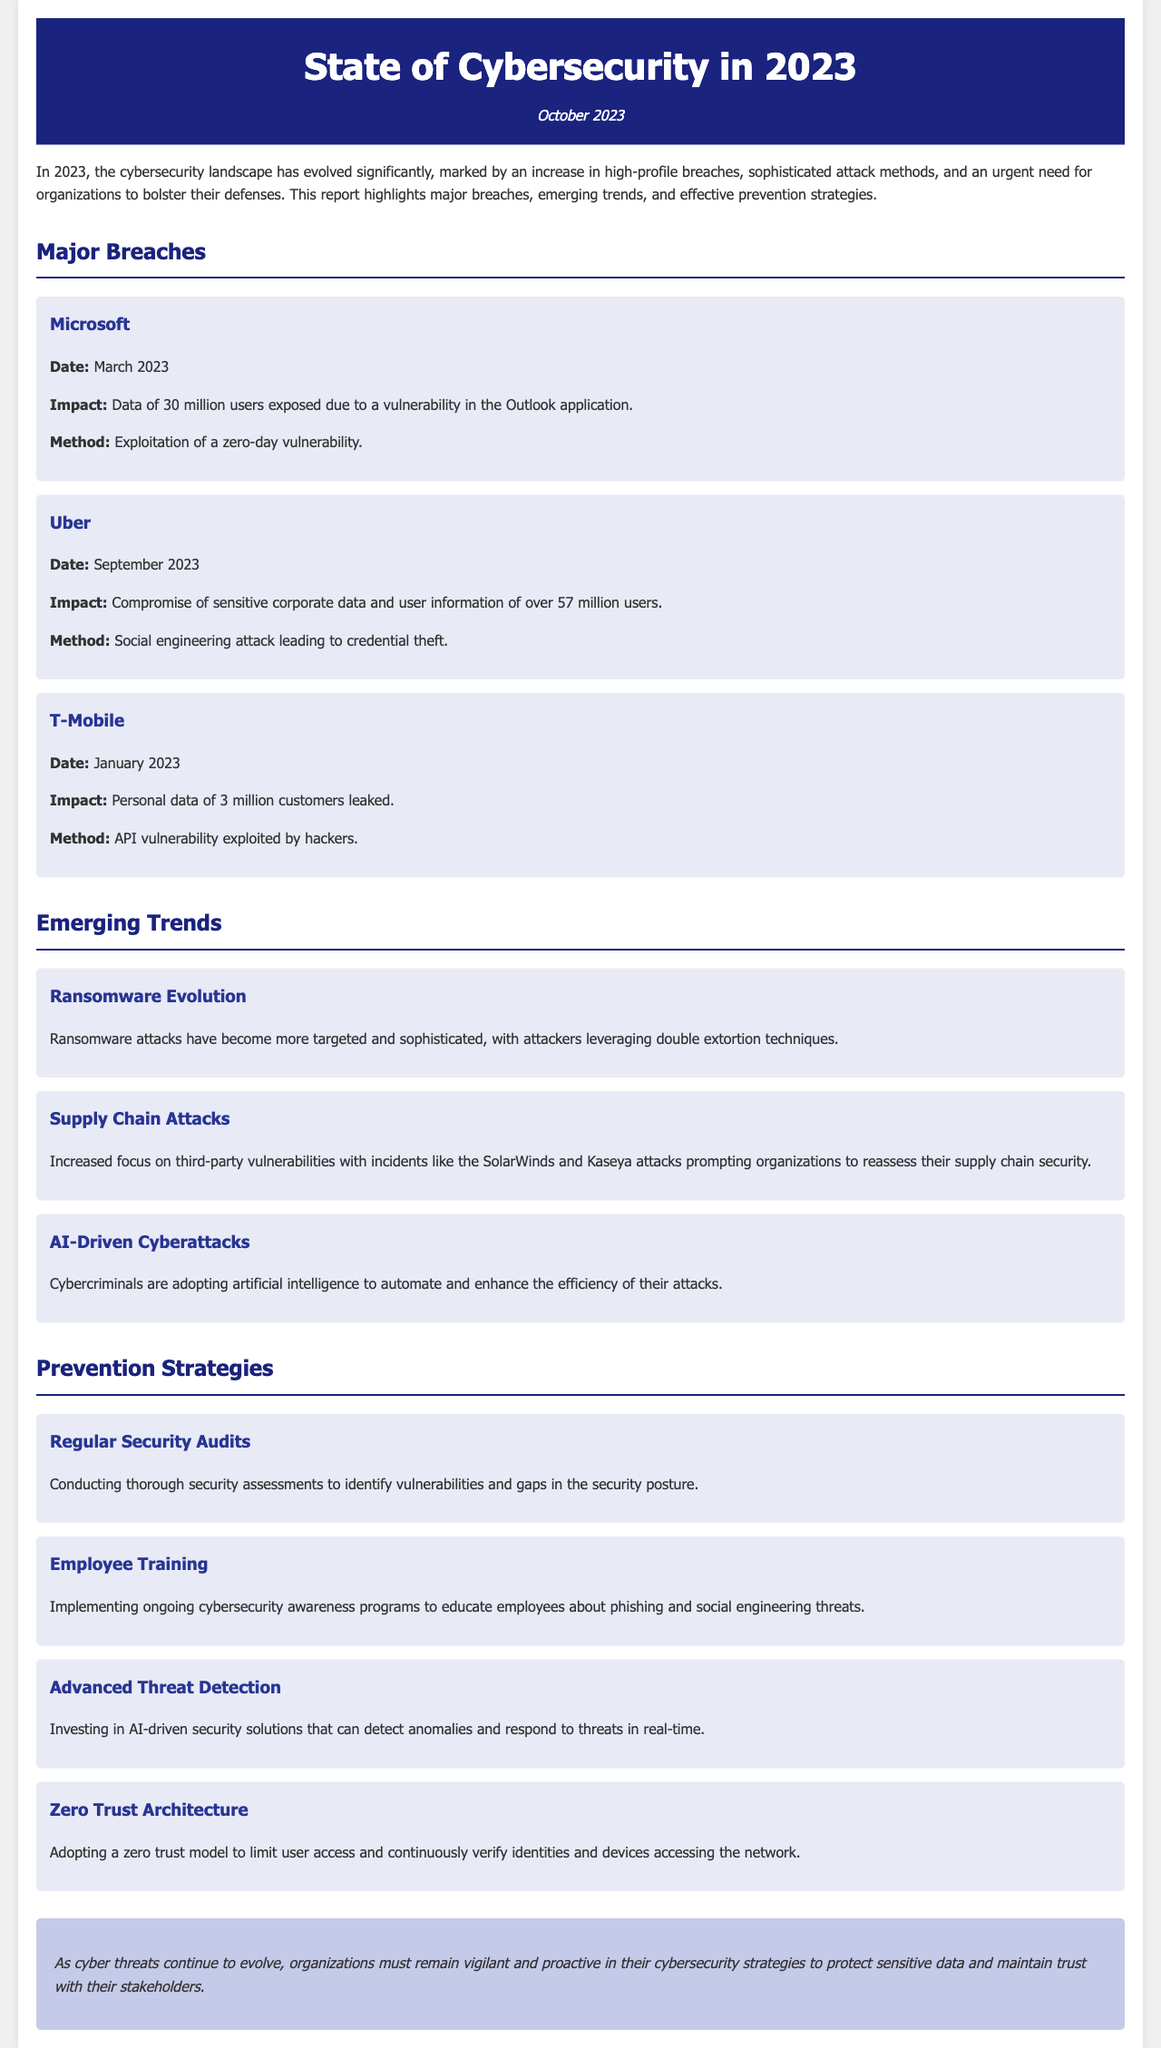What major breach occurred at Microsoft? The report specifies that Microsoft experienced a breach in March 2023 where data of 30 million users was exposed.
Answer: Microsoft What was the method used in the Uber breach? According to the report, the method used in the Uber breach was a social engineering attack leading to credential theft.
Answer: Social engineering attack How many customers' personal data were leaked in the T-Mobile breach? The document states that in the T-Mobile breach, personal data of 3 million customers was leaked.
Answer: 3 million What emerging trend involves targeted attacks and double extortion? The report identifies the evolution of ransomware attacks as an emerging trend characterized by targeted attacks and double extortion techniques.
Answer: Ransomware Evolution What strategy involves conducting thorough security assessments? The report mentions regular security audits as a strategy for identifying vulnerabilities and gaps in the security posture.
Answer: Regular Security Audits Which technology is being used by cybercriminals to automate attacks? The report mentions that AI is being adopted by cybercriminals to automate and enhance the efficiency of their attacks.
Answer: AI What date was the Uber breach reported? The document specifies that the Uber breach was reported in September 2023.
Answer: September 2023 What model does the report suggest for limiting user access? The report recommends adopting a zero trust architecture model to limit user access and verify identities continuously.
Answer: Zero Trust Architecture 